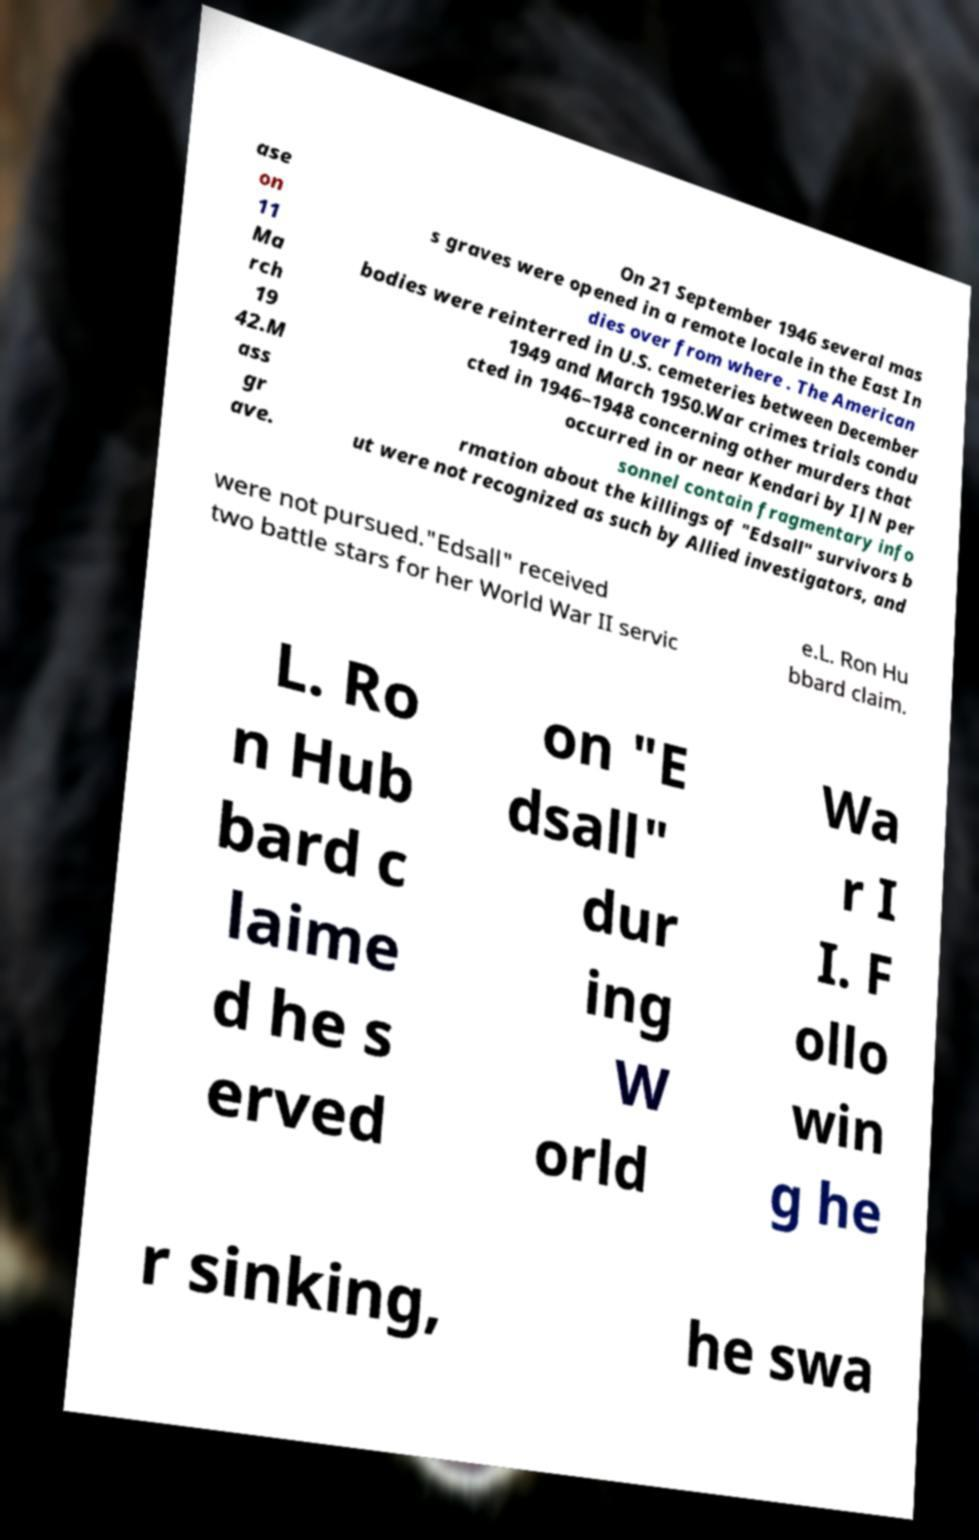There's text embedded in this image that I need extracted. Can you transcribe it verbatim? ase on 11 Ma rch 19 42.M ass gr ave. On 21 September 1946 several mas s graves were opened in a remote locale in the East In dies over from where . The American bodies were reinterred in U.S. cemeteries between December 1949 and March 1950.War crimes trials condu cted in 1946–1948 concerning other murders that occurred in or near Kendari by IJN per sonnel contain fragmentary info rmation about the killings of "Edsall" survivors b ut were not recognized as such by Allied investigators, and were not pursued."Edsall" received two battle stars for her World War II servic e.L. Ron Hu bbard claim. L. Ro n Hub bard c laime d he s erved on "E dsall" dur ing W orld Wa r I I. F ollo win g he r sinking, he swa 